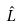Convert formula to latex. <formula><loc_0><loc_0><loc_500><loc_500>\hat { L }</formula> 